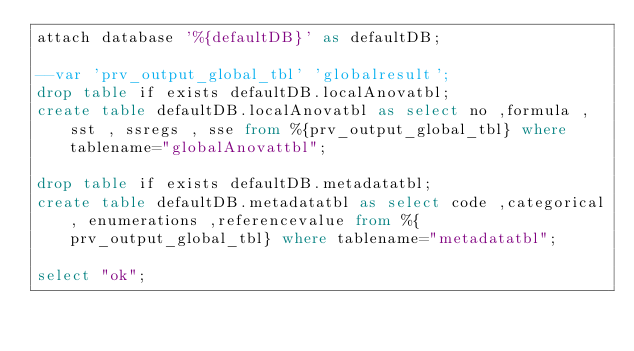Convert code to text. <code><loc_0><loc_0><loc_500><loc_500><_SQL_>attach database '%{defaultDB}' as defaultDB;

--var 'prv_output_global_tbl' 'globalresult';
drop table if exists defaultDB.localAnovatbl;
create table defaultDB.localAnovatbl as select no ,formula , sst , ssregs , sse from %{prv_output_global_tbl} where tablename="globalAnovattbl";

drop table if exists defaultDB.metadatatbl;
create table defaultDB.metadatatbl as select code ,categorical, enumerations ,referencevalue from %{prv_output_global_tbl} where tablename="metadatatbl";

select "ok";
</code> 